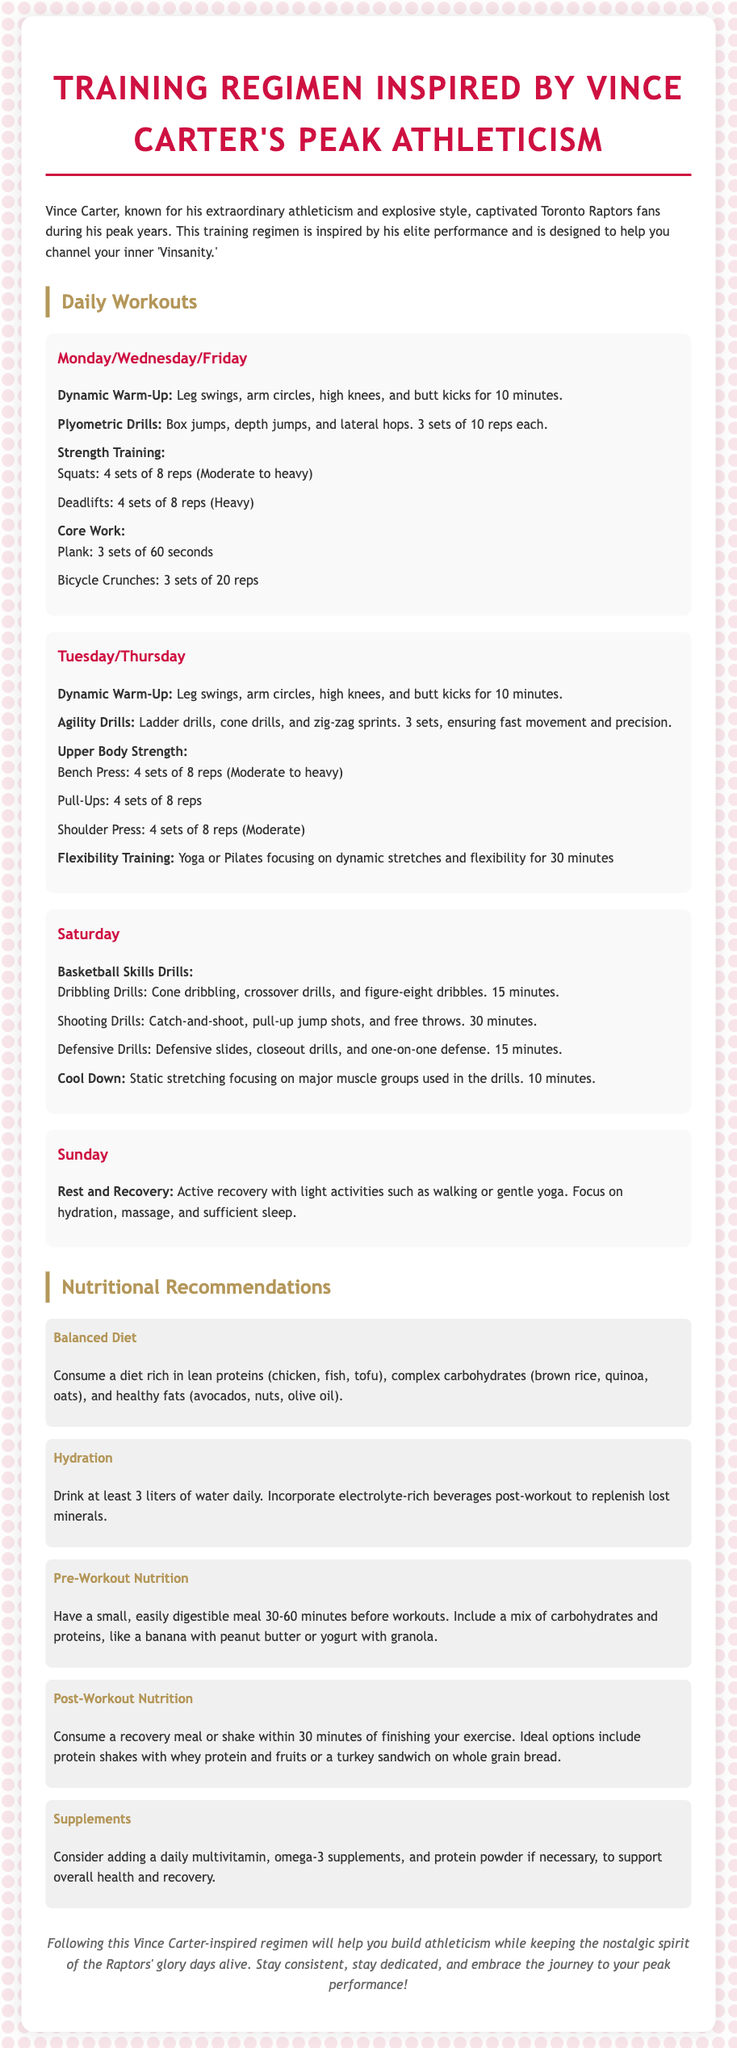What exercises are included in the dynamic warm-up? The dynamic warm-up includes leg swings, arm circles, high knees, and butt kicks.
Answer: leg swings, arm circles, high knees, and butt kicks How many sets and reps are recommended for box jumps? The document states that box jumps should be performed in 3 sets of 10 reps each.
Answer: 3 sets of 10 reps What type of nutrition is recommended pre-workout? The pre-workout nutrition recommendation suggests having a small, easily digestible meal including a mix of carbohydrates and proteins.
Answer: Mix of carbohydrates and proteins What is the total duration recommended for flexibility training on Tuesday and Thursday? Flexibility training is recommended to last for 30 minutes on both Tuesday and Thursday.
Answer: 30 minutes On which day is active recovery suggested? The document suggests active recovery on Sunday.
Answer: Sunday What is included in the post-workout nutrition? Post-workout nutrition recommends consuming a recovery meal or shake within 30 minutes of finishing exercise.
Answer: A recovery meal or shake How many liters of water are recommended to drink daily? The document specifies drinking at least 3 liters of water daily.
Answer: 3 liters What are the two main categories of workouts for Monday/Wednesday/Friday? The main categories of workouts are plyometric drills and strength training.
Answer: Plyometric drills and strength training 